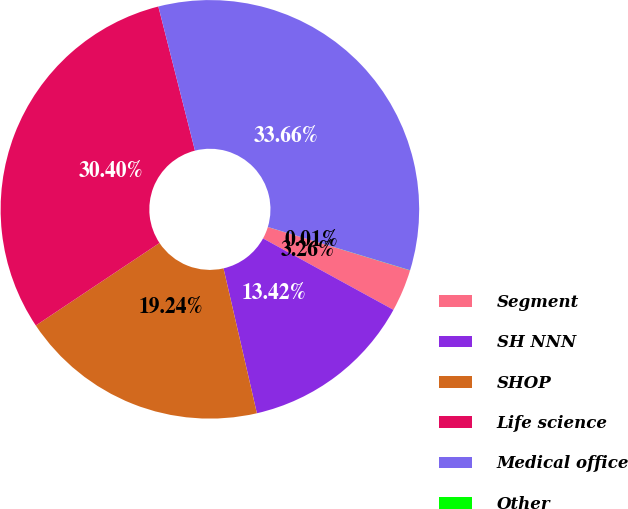Convert chart to OTSL. <chart><loc_0><loc_0><loc_500><loc_500><pie_chart><fcel>Segment<fcel>SH NNN<fcel>SHOP<fcel>Life science<fcel>Medical office<fcel>Other<nl><fcel>3.26%<fcel>13.42%<fcel>19.24%<fcel>30.4%<fcel>33.66%<fcel>0.01%<nl></chart> 